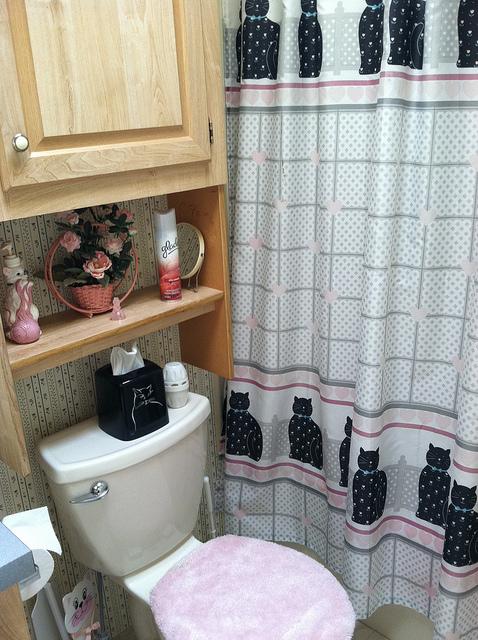What color is dominant?
Keep it brief. White. What purpose does the spray on the shelf have?
Quick response, please. Air freshener. Would you be able to take a shower in this room?
Answer briefly. Yes. 